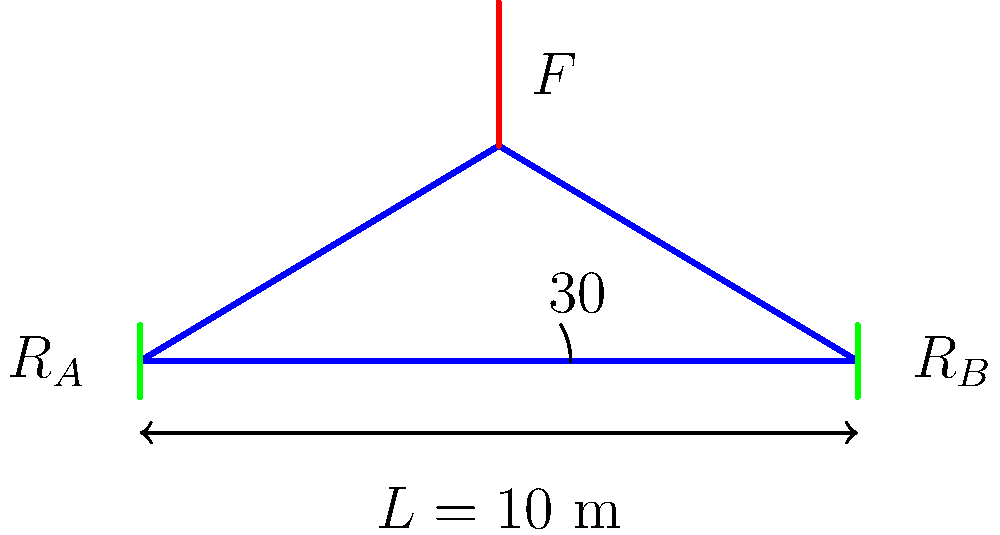As part of your collaboration with the local government to promote tourism, you're assessing the safety of a historic truss bridge that's popular among visitors. The bridge spans 10 meters and has a central peak 30° above horizontal. If a maximum load of 50 kN is applied at the peak, what is the compressive force in each of the two main truss members? To solve this problem, we'll follow these steps:

1) First, we need to understand the geometry of the bridge. The bridge forms an isosceles triangle with a base of 10 m and a peak angle of 30°.

2) We can calculate the length of each truss member using trigonometry:
   $$\text{Length} = \frac{10/2}{\cos 30°} = \frac{5}{\cos 30°} = 5.77 \text{ m}$$

3) The 50 kN force at the peak can be resolved into components along the truss members. Each member will carry half of the total load.

4) The angle between the force and each truss member is (90° - 30°) = 60°.

5) The force along each truss member can be calculated using:
   $$F_{\text{truss}} = \frac{50/2}{\cos 60°} = \frac{25}{\cos 60°} = 50 \text{ kN}$$

6) This force is compressive because it's pushing inward on the truss members.

Therefore, the compressive force in each of the two main truss members is 50 kN.
Answer: 50 kN 